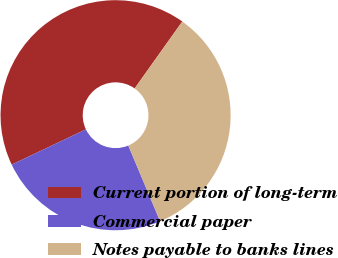<chart> <loc_0><loc_0><loc_500><loc_500><pie_chart><fcel>Current portion of long-term<fcel>Commercial paper<fcel>Notes payable to banks lines<nl><fcel>41.91%<fcel>24.26%<fcel>33.82%<nl></chart> 